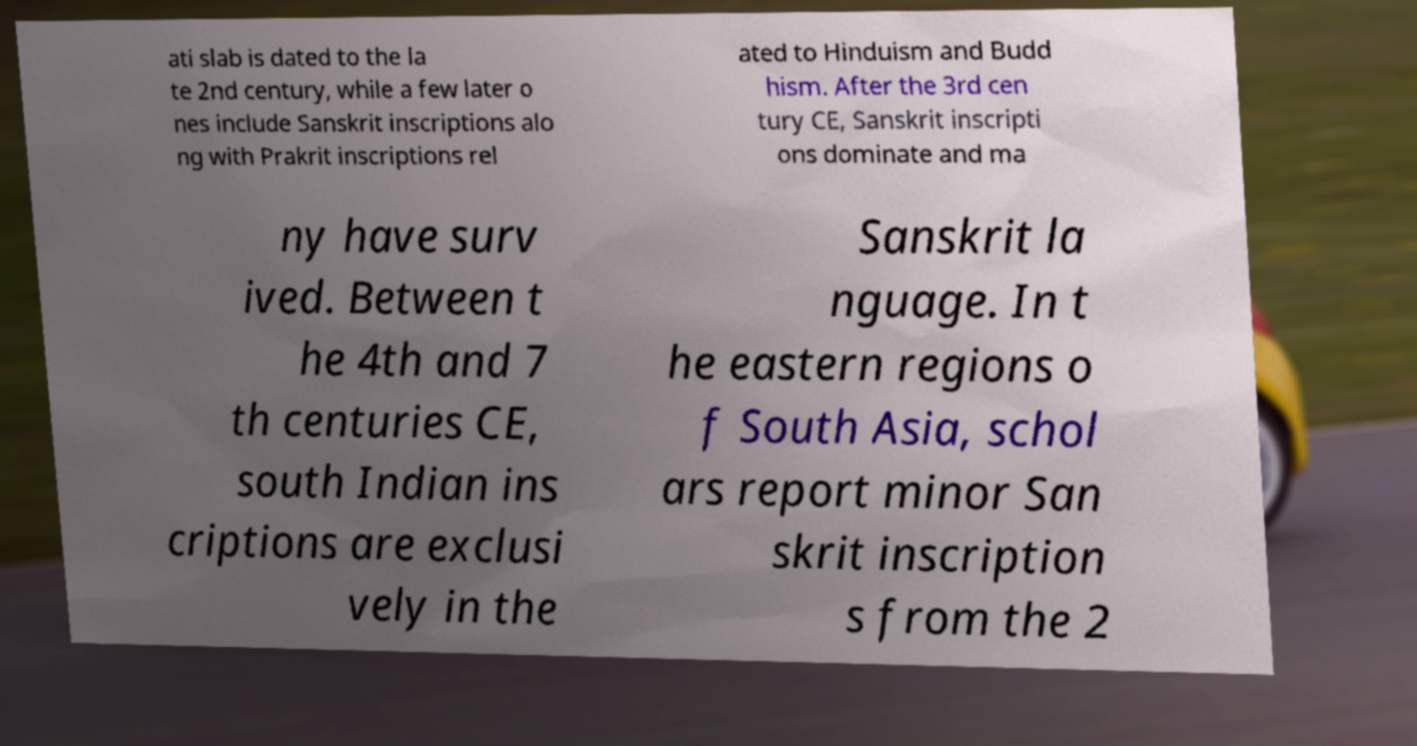I need the written content from this picture converted into text. Can you do that? ati slab is dated to the la te 2nd century, while a few later o nes include Sanskrit inscriptions alo ng with Prakrit inscriptions rel ated to Hinduism and Budd hism. After the 3rd cen tury CE, Sanskrit inscripti ons dominate and ma ny have surv ived. Between t he 4th and 7 th centuries CE, south Indian ins criptions are exclusi vely in the Sanskrit la nguage. In t he eastern regions o f South Asia, schol ars report minor San skrit inscription s from the 2 